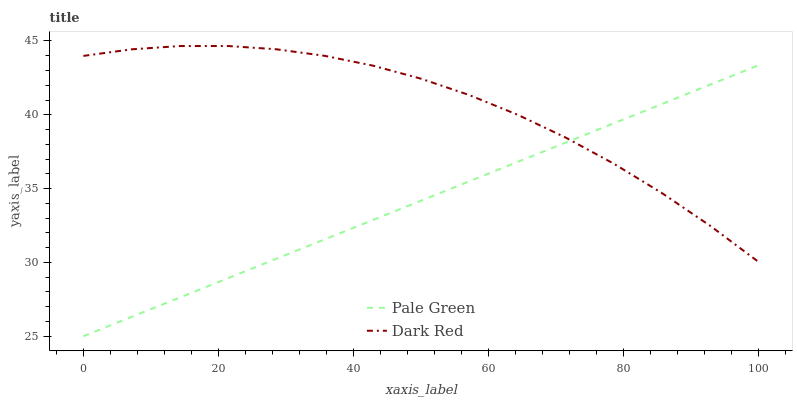Does Pale Green have the minimum area under the curve?
Answer yes or no. Yes. Does Dark Red have the maximum area under the curve?
Answer yes or no. Yes. Does Pale Green have the maximum area under the curve?
Answer yes or no. No. Is Pale Green the smoothest?
Answer yes or no. Yes. Is Dark Red the roughest?
Answer yes or no. Yes. Is Pale Green the roughest?
Answer yes or no. No. Does Pale Green have the lowest value?
Answer yes or no. Yes. Does Dark Red have the highest value?
Answer yes or no. Yes. Does Pale Green have the highest value?
Answer yes or no. No. Does Dark Red intersect Pale Green?
Answer yes or no. Yes. Is Dark Red less than Pale Green?
Answer yes or no. No. Is Dark Red greater than Pale Green?
Answer yes or no. No. 